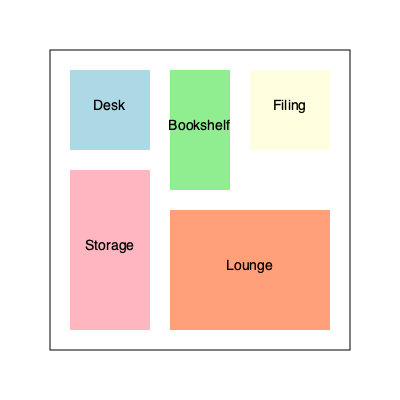In designing an efficient home office setup, you need to arrange five furniture pieces: a desk, a bookshelf, a filing cabinet, a storage unit, and a lounge area. The image shows a top-down view of a possible arrangement. If you were to rotate the bookshelf 90 degrees clockwise and swap the positions of the filing cabinet and storage unit, how many furniture pieces would be touching at least two walls of the room? Let's approach this step-by-step:

1. Current arrangement:
   - Desk: touches 2 walls
   - Bookshelf: touches 1 wall
   - Filing cabinet: touches 2 walls
   - Storage unit: touches 2 walls
   - Lounge area: touches 2 walls

2. After rotating the bookshelf 90 degrees clockwise:
   - The bookshelf will now touch 2 walls (left and bottom)

3. After swapping the filing cabinet and storage unit:
   - The filing cabinet will now touch 2 walls (left and bottom)
   - The storage unit will now touch 2 walls (right and top)

4. Final arrangement:
   - Desk: touches 2 walls
   - Bookshelf: touches 2 walls
   - Filing cabinet: touches 2 walls
   - Storage unit: touches 2 walls
   - Lounge area: touches 2 walls

5. Count the furniture pieces touching at least two walls:
   All 5 pieces of furniture are now touching at least two walls.
Answer: 5 